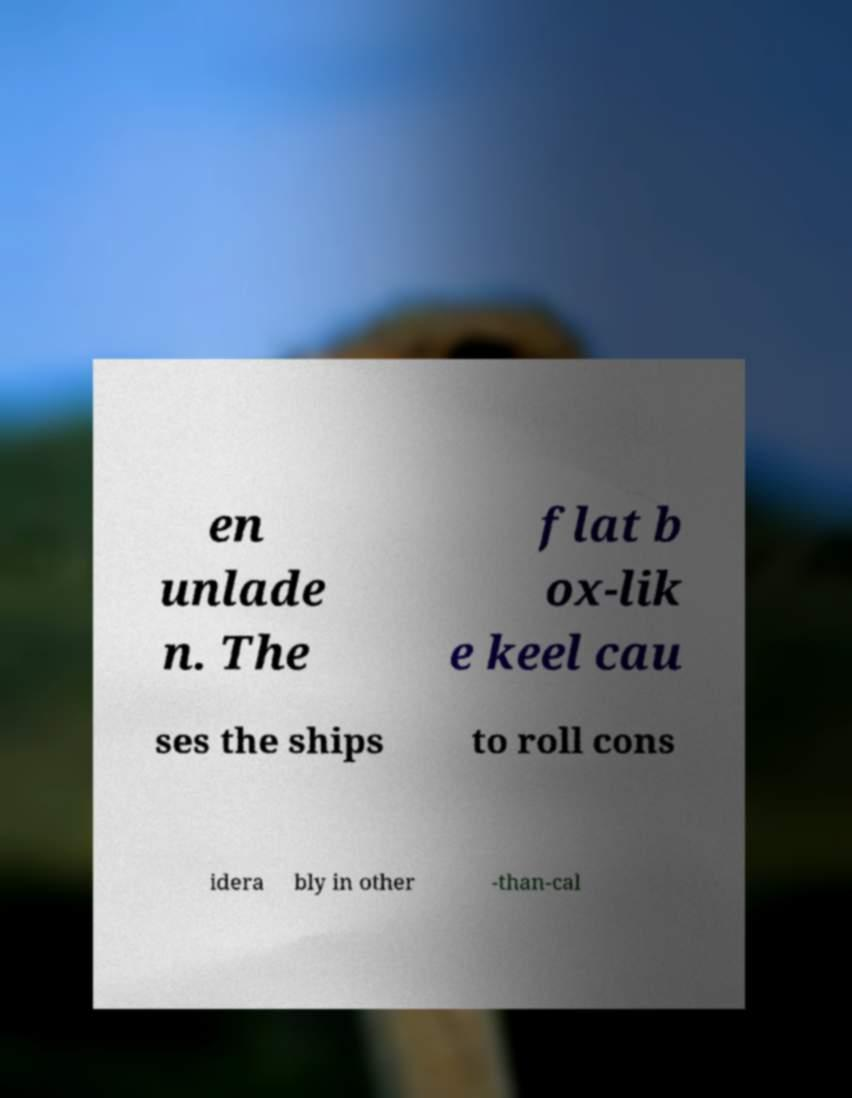Please identify and transcribe the text found in this image. en unlade n. The flat b ox-lik e keel cau ses the ships to roll cons idera bly in other -than-cal 